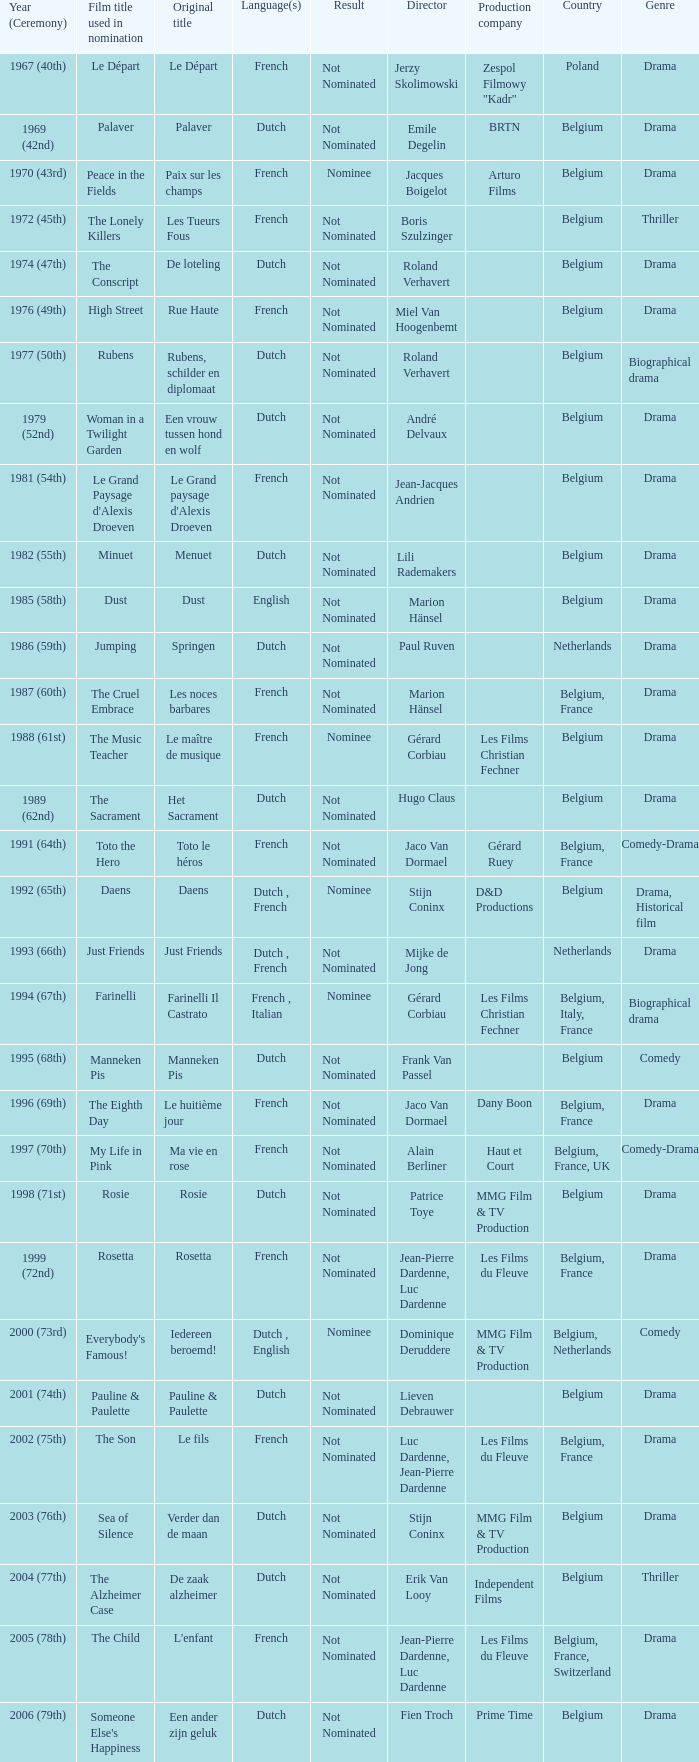What is the language of the film Rosie? Dutch. 